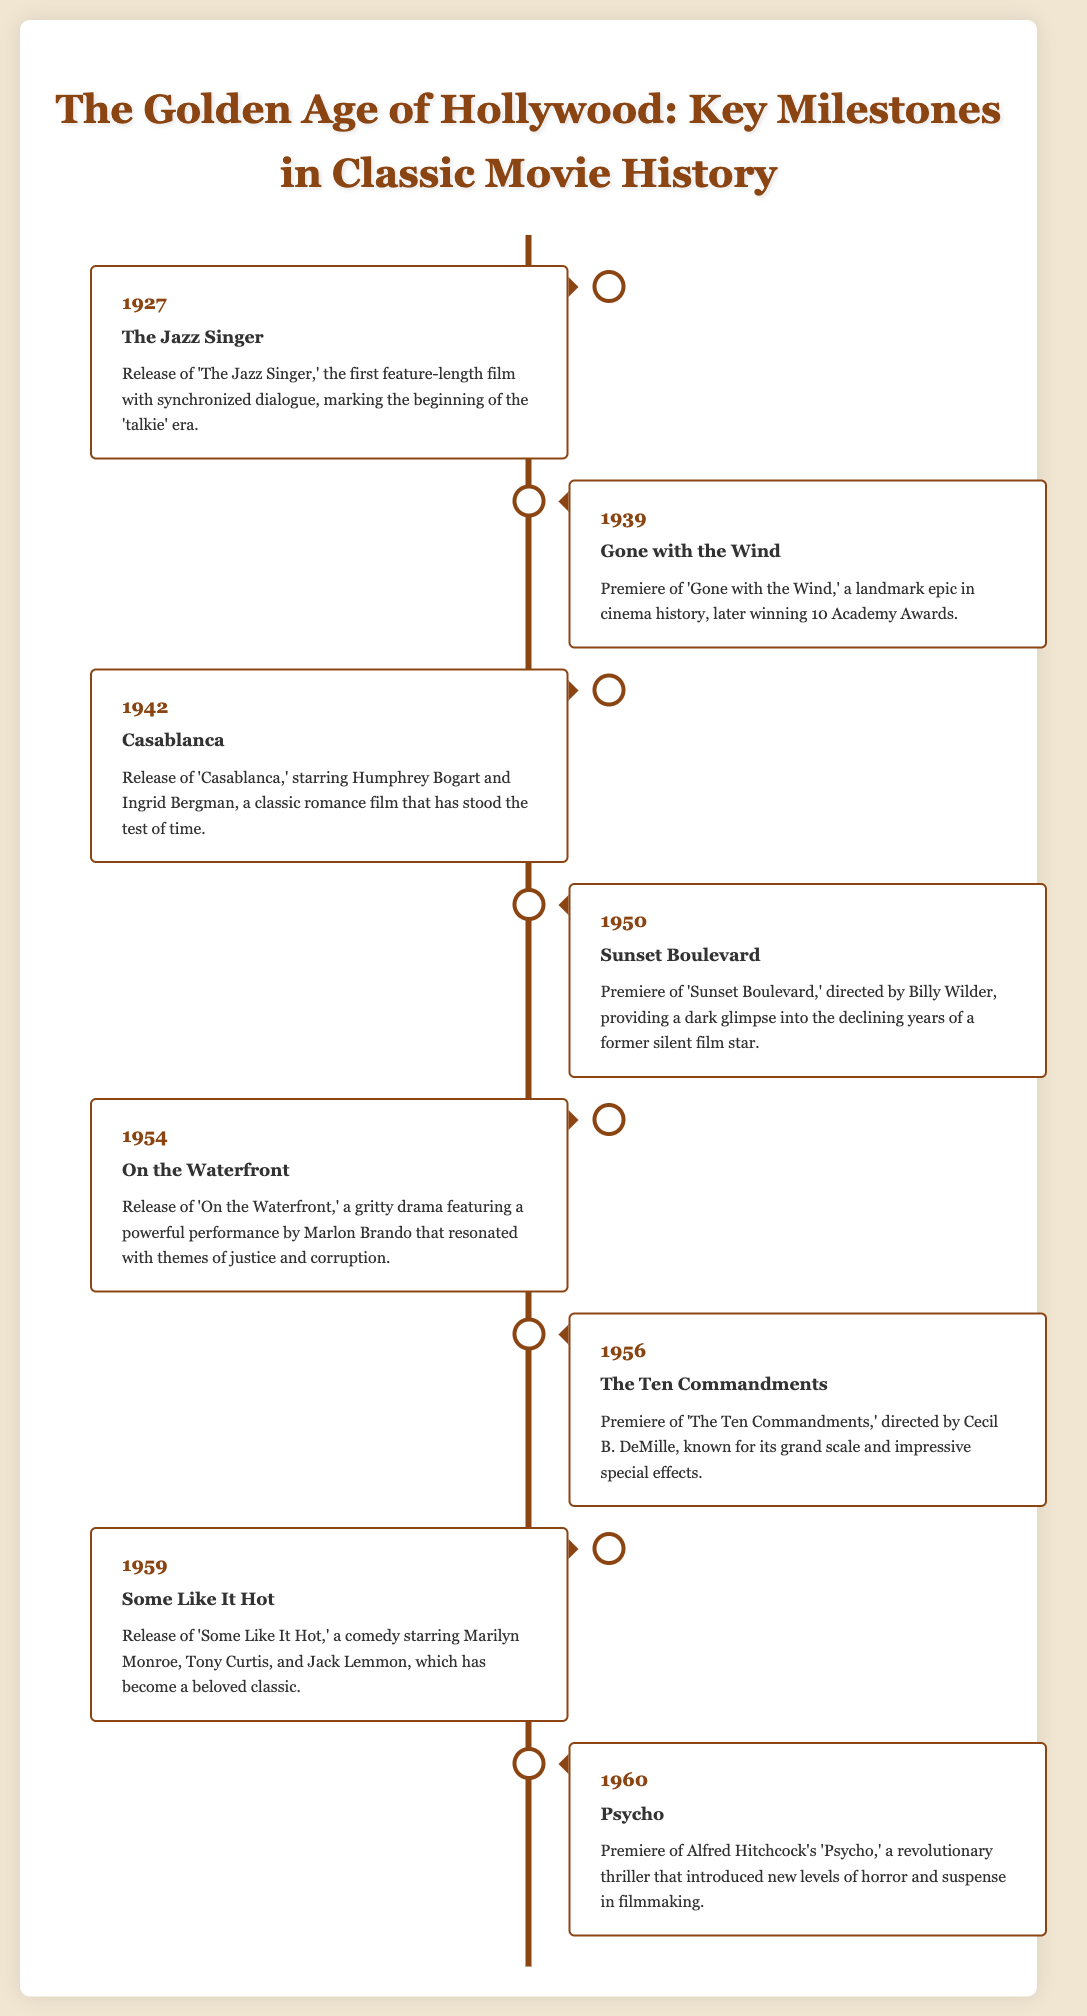What film marked the beginning of the 'talkie' era? The document states that 'The Jazz Singer' was the first feature-length film with synchronized dialogue, marking the start of the 'talkie' era.
Answer: The Jazz Singer Which film won 10 Academy Awards? The document mentions that 'Gone with the Wind' premiered and later won 10 Academy Awards.
Answer: Gone with the Wind In what year was 'Casablanca' released? The timeline specifies that 'Casablanca' was released in 1942.
Answer: 1942 Who directed 'Sunset Boulevard'? According to the document, 'Sunset Boulevard' was directed by Billy Wilder.
Answer: Billy Wilder What genre is 'Some Like It Hot'? The description in the document classifies 'Some Like It Hot' as a comedy.
Answer: Comedy Which film featured a revolutionary thriller approach in 1960? The document describes Alfred Hitchcock's 'Psycho' as a revolutionary thriller that introduced new levels of horror and suspense.
Answer: Psycho What themes did 'On the Waterfront' resonate with? The timeline states that 'On the Waterfront' featured themes of justice and corruption.
Answer: Justice and corruption What is a unique feature of the document? The document is structured as a timeline infographic, showing key milestones in classic movie history.
Answer: Timeline infographic 